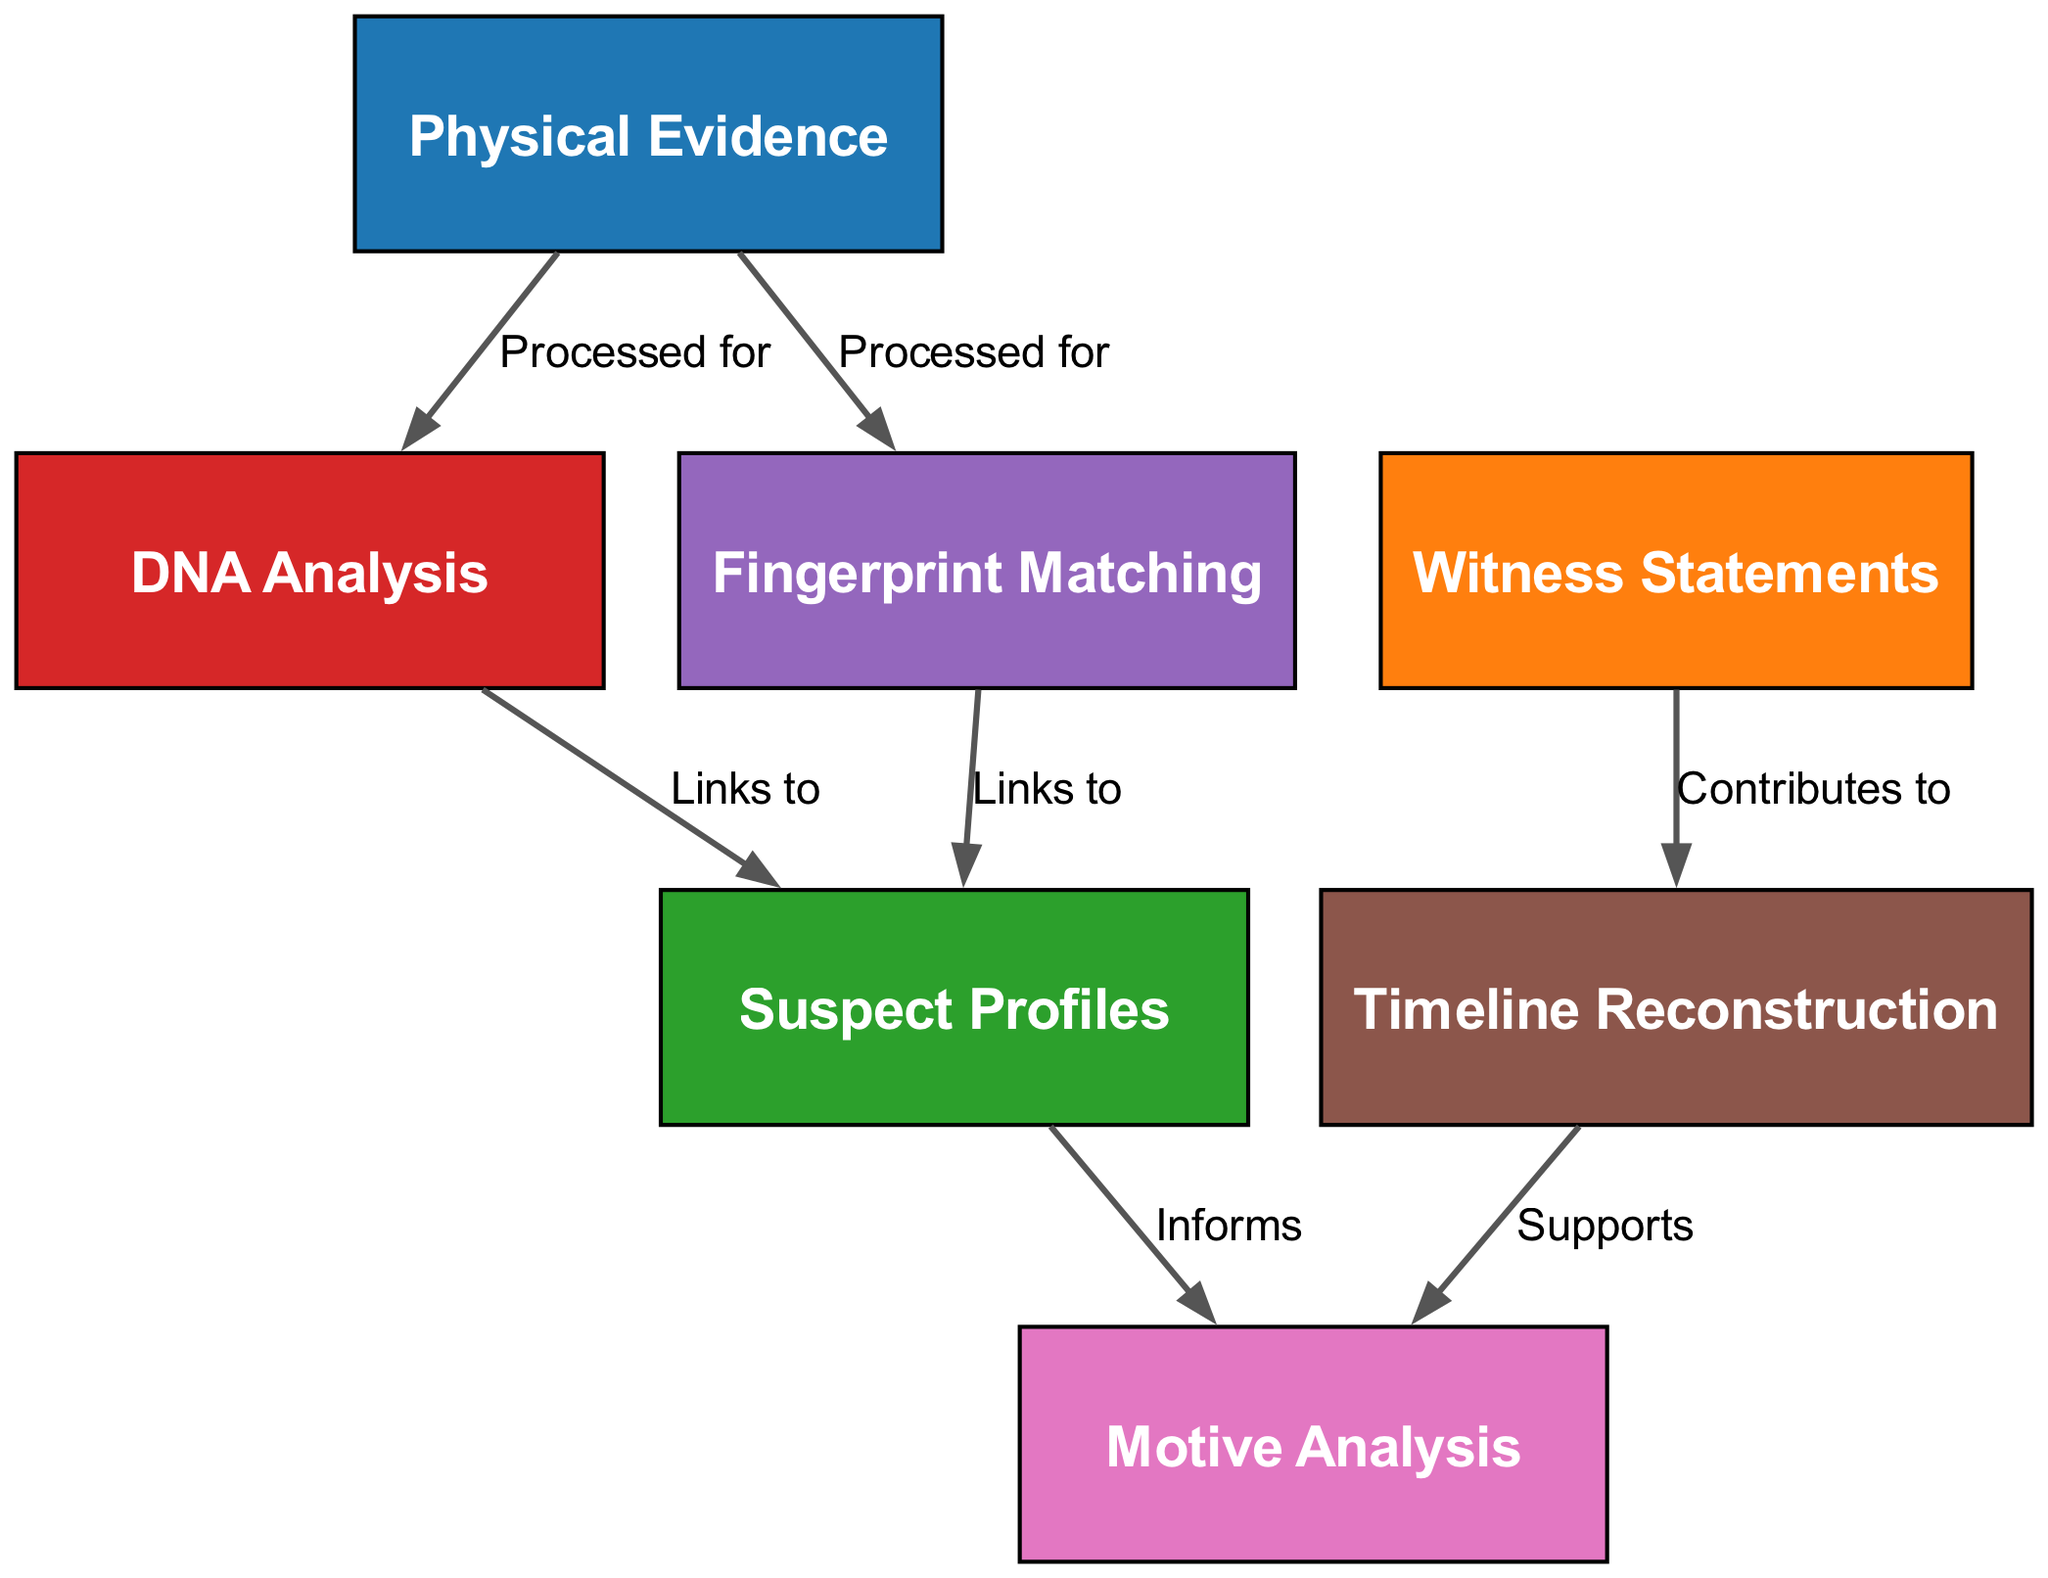What are the three main components analyzed in this evidence analysis system? The diagram features three main components: Physical Evidence, Witness Statements, and Suspect Profiles. These are marked as distinct nodes in the diagram.
Answer: Physical Evidence, Witness Statements, Suspect Profiles How many edges are there in the diagram? The diagram consists of six edges that connect the various nodes and represent their relationships as described in the data provided.
Answer: 6 What process links Physical Evidence to DNA Analysis? The edge from Physical Evidence to DNA Analysis is labeled "Processed for," indicating that the physical evidence undergoes this specific type of analysis.
Answer: Processed for Which component informs the Motive Analysis? The diagram shows that Suspect Profiles informs Motive Analysis, as indicated by the respective edge linking these two nodes.
Answer: Suspect Profiles What does the Witness Statements contribute to in the system? The diagram specifies that Witness Statements contribute to Timeline Reconstruction, as highlighted by the connection in the edges.
Answer: Timeline Reconstruction How does Timeline Reconstruction relate to Motive Analysis? The diagram shows an edge from Timeline Reconstruction to Motive Analysis labeled "Supports," indicating that the reconstruction of timelines provides supportive information for analyzing motives.
Answer: Supports 